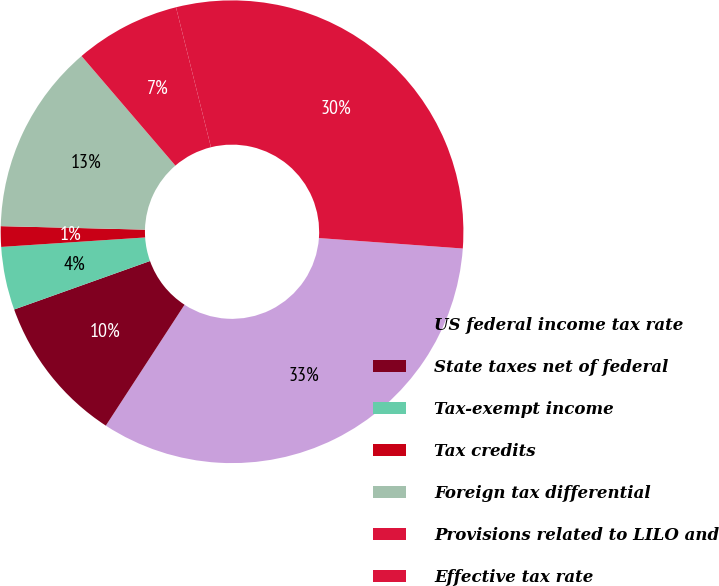Convert chart. <chart><loc_0><loc_0><loc_500><loc_500><pie_chart><fcel>US federal income tax rate<fcel>State taxes net of federal<fcel>Tax-exempt income<fcel>Tax credits<fcel>Foreign tax differential<fcel>Provisions related to LILO and<fcel>Effective tax rate<nl><fcel>33.03%<fcel>10.36%<fcel>4.41%<fcel>1.43%<fcel>13.34%<fcel>7.38%<fcel>30.05%<nl></chart> 